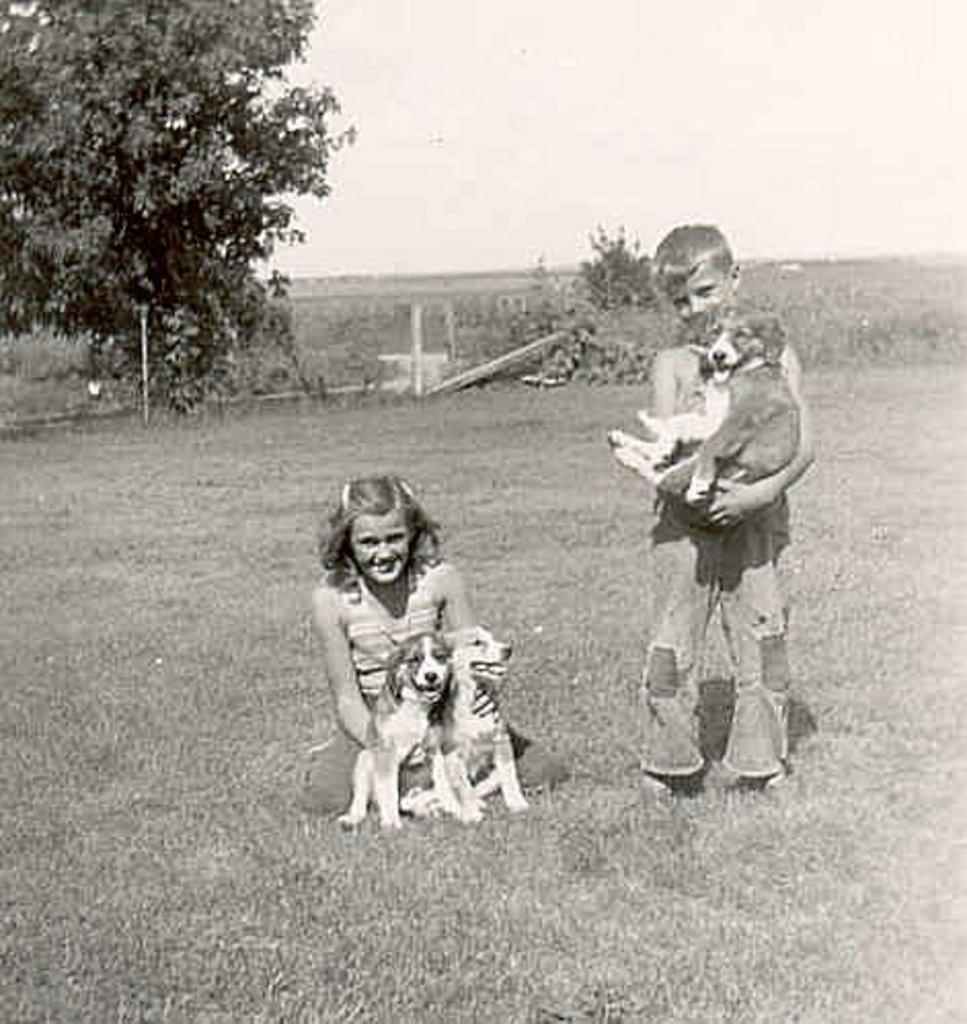How would you summarize this image in a sentence or two? there are two people holding dogs. behind them there are trees. 